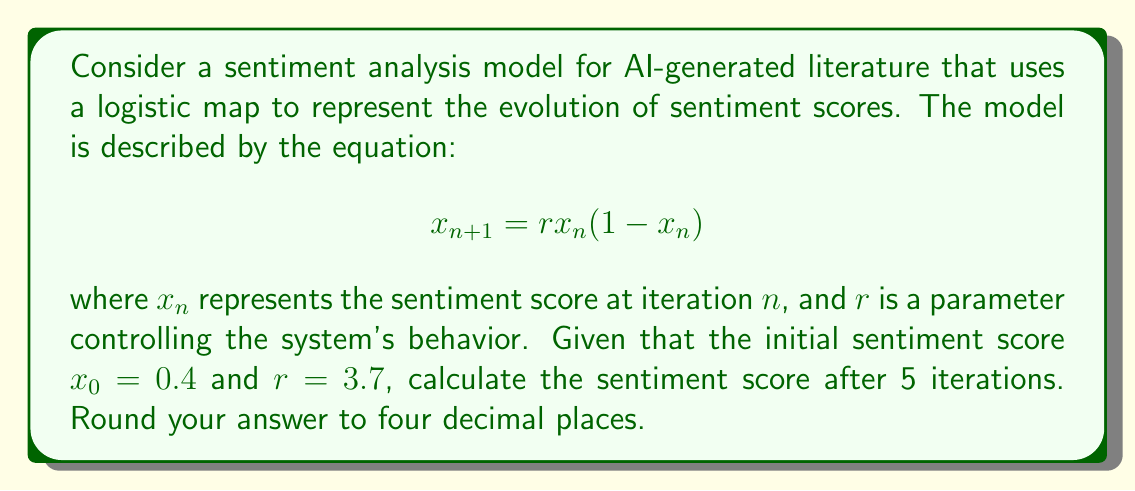Teach me how to tackle this problem. To solve this problem, we need to iterate the logistic map equation five times, starting with the given initial condition. Let's proceed step by step:

1) For $n = 0$:
   $x_0 = 0.4$ (given)

2) For $n = 1$:
   $x_1 = r \cdot x_0 \cdot (1-x_0) = 3.7 \cdot 0.4 \cdot (1-0.4) = 0.888$

3) For $n = 2$:
   $x_2 = r \cdot x_1 \cdot (1-x_1) = 3.7 \cdot 0.888 \cdot (1-0.888) = 0.3681216$

4) For $n = 3$:
   $x_3 = r \cdot x_2 \cdot (1-x_2) = 3.7 \cdot 0.3681216 \cdot (1-0.3681216) = 0.8611356$

5) For $n = 4$:
   $x_4 = r \cdot x_3 \cdot (1-x_3) = 3.7 \cdot 0.8611356 \cdot (1-0.8611356) = 0.4431488$

6) For $n = 5$:
   $x_5 = r \cdot x_4 \cdot (1-x_4) = 3.7 \cdot 0.4431488 \cdot (1-0.4431488) = 0.9132658$

Rounding to four decimal places, we get 0.9133.
Answer: 0.9133 